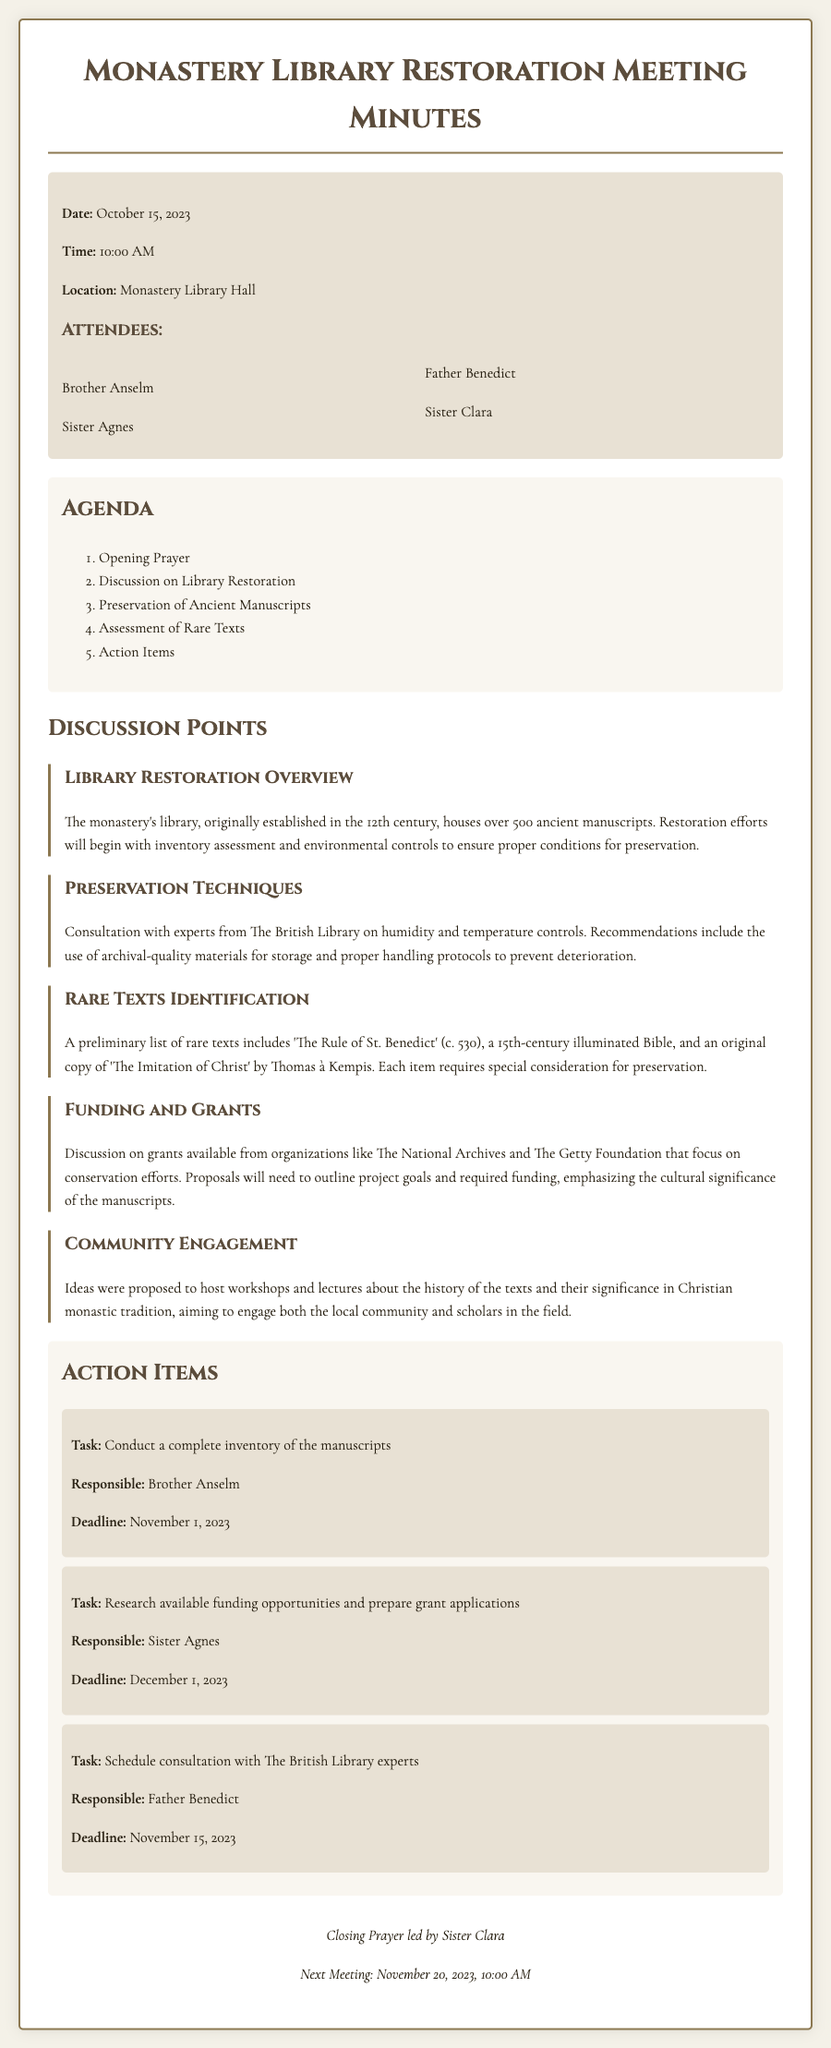What is the date of the meeting? The date of the meeting is explicitly stated in the document.
Answer: October 15, 2023 Who is responsible for conducting the inventory of the manuscripts? The document specifies who is responsible for each action item, including the inventory task.
Answer: Brother Anselm What ancient text from the preliminary list is dated around 530? The document mentions specific texts along with their historical dates.
Answer: The Rule of St. Benedict How many manuscripts does the monastery's library house? The document states the total number of manuscripts in the library.
Answer: Over 500 What is the deadline for the research on funding opportunities? The deadlines for each action item are clearly listed in the meeting minutes.
Answer: December 1, 2023 Which Sister led the closing prayer? The document identifies who led the closing prayer at the end of the meeting.
Answer: Sister Clara Name one of the organizations mentioned for potential grants. The document lists organizations that offer grants for restoration efforts.
Answer: The National Archives What is one of the proposed activities to engage the community? The document outlines ideas for community engagement in the context of the library restoration.
Answer: Host workshops What is the location of the meeting? The location where the meeting took place is indicated in the document.
Answer: Monastery Library Hall 